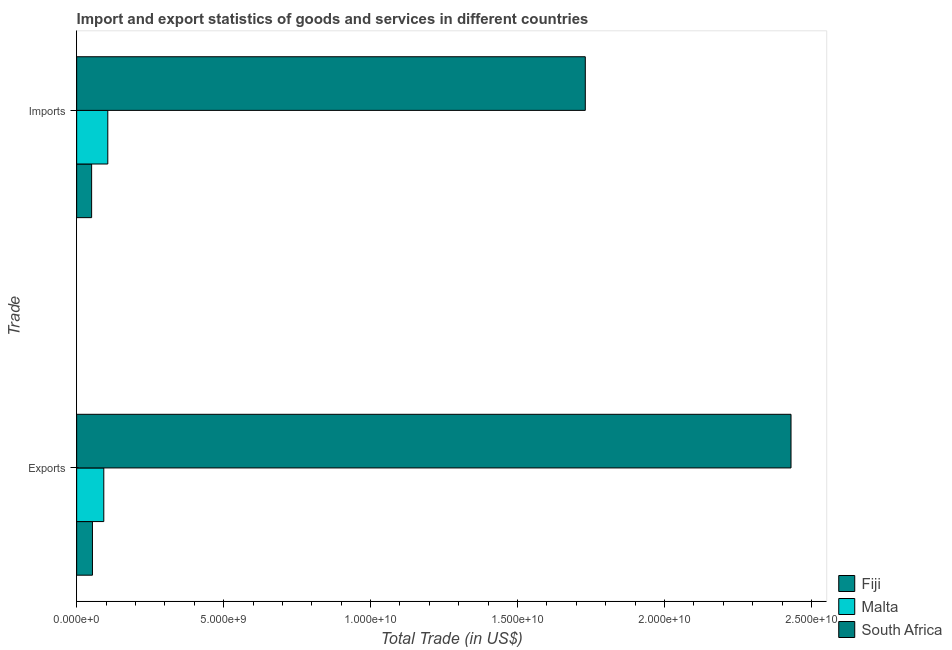How many different coloured bars are there?
Your answer should be very brief. 3. How many groups of bars are there?
Ensure brevity in your answer.  2. Are the number of bars per tick equal to the number of legend labels?
Give a very brief answer. Yes. How many bars are there on the 1st tick from the bottom?
Provide a short and direct response. 3. What is the label of the 2nd group of bars from the top?
Provide a succinct answer. Exports. What is the export of goods and services in South Africa?
Give a very brief answer. 2.43e+1. Across all countries, what is the maximum export of goods and services?
Your response must be concise. 2.43e+1. Across all countries, what is the minimum imports of goods and services?
Keep it short and to the point. 5.09e+08. In which country was the export of goods and services maximum?
Your answer should be very brief. South Africa. In which country was the imports of goods and services minimum?
Give a very brief answer. Fiji. What is the total export of goods and services in the graph?
Make the answer very short. 2.58e+1. What is the difference between the imports of goods and services in Fiji and that in Malta?
Your answer should be very brief. -5.50e+08. What is the difference between the export of goods and services in Fiji and the imports of goods and services in Malta?
Make the answer very short. -5.22e+08. What is the average export of goods and services per country?
Ensure brevity in your answer.  8.59e+09. What is the difference between the imports of goods and services and export of goods and services in Malta?
Provide a succinct answer. 1.36e+08. In how many countries, is the export of goods and services greater than 15000000000 US$?
Your answer should be very brief. 1. What is the ratio of the imports of goods and services in Fiji to that in South Africa?
Provide a short and direct response. 0.03. In how many countries, is the export of goods and services greater than the average export of goods and services taken over all countries?
Your response must be concise. 1. What does the 3rd bar from the top in Exports represents?
Your response must be concise. Fiji. What does the 1st bar from the bottom in Imports represents?
Your answer should be compact. Fiji. Are all the bars in the graph horizontal?
Your answer should be very brief. Yes. Are the values on the major ticks of X-axis written in scientific E-notation?
Your response must be concise. Yes. Does the graph contain any zero values?
Your answer should be very brief. No. Does the graph contain grids?
Give a very brief answer. No. How many legend labels are there?
Provide a succinct answer. 3. How are the legend labels stacked?
Offer a very short reply. Vertical. What is the title of the graph?
Ensure brevity in your answer.  Import and export statistics of goods and services in different countries. What is the label or title of the X-axis?
Your answer should be very brief. Total Trade (in US$). What is the label or title of the Y-axis?
Give a very brief answer. Trade. What is the Total Trade (in US$) in Fiji in Exports?
Provide a short and direct response. 5.38e+08. What is the Total Trade (in US$) of Malta in Exports?
Keep it short and to the point. 9.23e+08. What is the Total Trade (in US$) in South Africa in Exports?
Provide a succinct answer. 2.43e+1. What is the Total Trade (in US$) of Fiji in Imports?
Ensure brevity in your answer.  5.09e+08. What is the Total Trade (in US$) in Malta in Imports?
Offer a very short reply. 1.06e+09. What is the Total Trade (in US$) of South Africa in Imports?
Offer a very short reply. 1.73e+1. Across all Trade, what is the maximum Total Trade (in US$) of Fiji?
Provide a short and direct response. 5.38e+08. Across all Trade, what is the maximum Total Trade (in US$) in Malta?
Ensure brevity in your answer.  1.06e+09. Across all Trade, what is the maximum Total Trade (in US$) in South Africa?
Give a very brief answer. 2.43e+1. Across all Trade, what is the minimum Total Trade (in US$) of Fiji?
Keep it short and to the point. 5.09e+08. Across all Trade, what is the minimum Total Trade (in US$) of Malta?
Your response must be concise. 9.23e+08. Across all Trade, what is the minimum Total Trade (in US$) in South Africa?
Ensure brevity in your answer.  1.73e+1. What is the total Total Trade (in US$) of Fiji in the graph?
Give a very brief answer. 1.05e+09. What is the total Total Trade (in US$) of Malta in the graph?
Your answer should be compact. 1.98e+09. What is the total Total Trade (in US$) in South Africa in the graph?
Give a very brief answer. 4.16e+1. What is the difference between the Total Trade (in US$) of Fiji in Exports and that in Imports?
Keep it short and to the point. 2.82e+07. What is the difference between the Total Trade (in US$) in Malta in Exports and that in Imports?
Make the answer very short. -1.36e+08. What is the difference between the Total Trade (in US$) in South Africa in Exports and that in Imports?
Provide a succinct answer. 7.00e+09. What is the difference between the Total Trade (in US$) in Fiji in Exports and the Total Trade (in US$) in Malta in Imports?
Your response must be concise. -5.22e+08. What is the difference between the Total Trade (in US$) of Fiji in Exports and the Total Trade (in US$) of South Africa in Imports?
Ensure brevity in your answer.  -1.68e+1. What is the difference between the Total Trade (in US$) in Malta in Exports and the Total Trade (in US$) in South Africa in Imports?
Give a very brief answer. -1.64e+1. What is the average Total Trade (in US$) in Fiji per Trade?
Your answer should be compact. 5.23e+08. What is the average Total Trade (in US$) of Malta per Trade?
Your answer should be very brief. 9.91e+08. What is the average Total Trade (in US$) of South Africa per Trade?
Ensure brevity in your answer.  2.08e+1. What is the difference between the Total Trade (in US$) in Fiji and Total Trade (in US$) in Malta in Exports?
Make the answer very short. -3.86e+08. What is the difference between the Total Trade (in US$) in Fiji and Total Trade (in US$) in South Africa in Exports?
Your response must be concise. -2.38e+1. What is the difference between the Total Trade (in US$) of Malta and Total Trade (in US$) of South Africa in Exports?
Give a very brief answer. -2.34e+1. What is the difference between the Total Trade (in US$) of Fiji and Total Trade (in US$) of Malta in Imports?
Offer a terse response. -5.50e+08. What is the difference between the Total Trade (in US$) in Fiji and Total Trade (in US$) in South Africa in Imports?
Your response must be concise. -1.68e+1. What is the difference between the Total Trade (in US$) in Malta and Total Trade (in US$) in South Africa in Imports?
Offer a very short reply. -1.62e+1. What is the ratio of the Total Trade (in US$) in Fiji in Exports to that in Imports?
Provide a succinct answer. 1.06. What is the ratio of the Total Trade (in US$) in Malta in Exports to that in Imports?
Keep it short and to the point. 0.87. What is the ratio of the Total Trade (in US$) of South Africa in Exports to that in Imports?
Offer a very short reply. 1.4. What is the difference between the highest and the second highest Total Trade (in US$) of Fiji?
Your response must be concise. 2.82e+07. What is the difference between the highest and the second highest Total Trade (in US$) in Malta?
Offer a very short reply. 1.36e+08. What is the difference between the highest and the second highest Total Trade (in US$) in South Africa?
Offer a very short reply. 7.00e+09. What is the difference between the highest and the lowest Total Trade (in US$) of Fiji?
Provide a short and direct response. 2.82e+07. What is the difference between the highest and the lowest Total Trade (in US$) in Malta?
Provide a succinct answer. 1.36e+08. What is the difference between the highest and the lowest Total Trade (in US$) of South Africa?
Offer a terse response. 7.00e+09. 